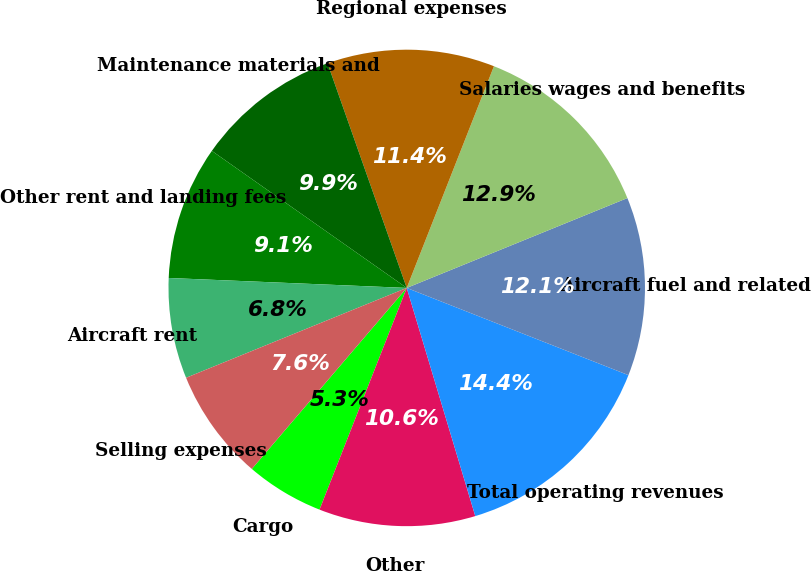Convert chart to OTSL. <chart><loc_0><loc_0><loc_500><loc_500><pie_chart><fcel>Cargo<fcel>Other<fcel>Total operating revenues<fcel>Aircraft fuel and related<fcel>Salaries wages and benefits<fcel>Regional expenses<fcel>Maintenance materials and<fcel>Other rent and landing fees<fcel>Aircraft rent<fcel>Selling expenses<nl><fcel>5.3%<fcel>10.61%<fcel>14.39%<fcel>12.12%<fcel>12.88%<fcel>11.36%<fcel>9.85%<fcel>9.09%<fcel>6.82%<fcel>7.58%<nl></chart> 